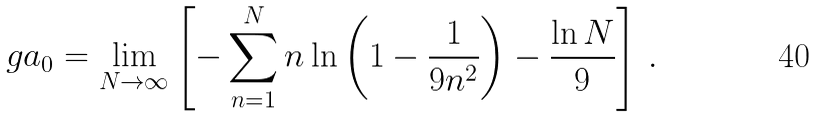<formula> <loc_0><loc_0><loc_500><loc_500>\ g a _ { 0 } = \lim _ { N \to \infty } \left [ - \sum _ { n = 1 } ^ { N } n \ln \left ( 1 - \frac { 1 } { 9 n ^ { 2 } } \right ) - \frac { \ln N } { 9 } \right ] \, .</formula> 